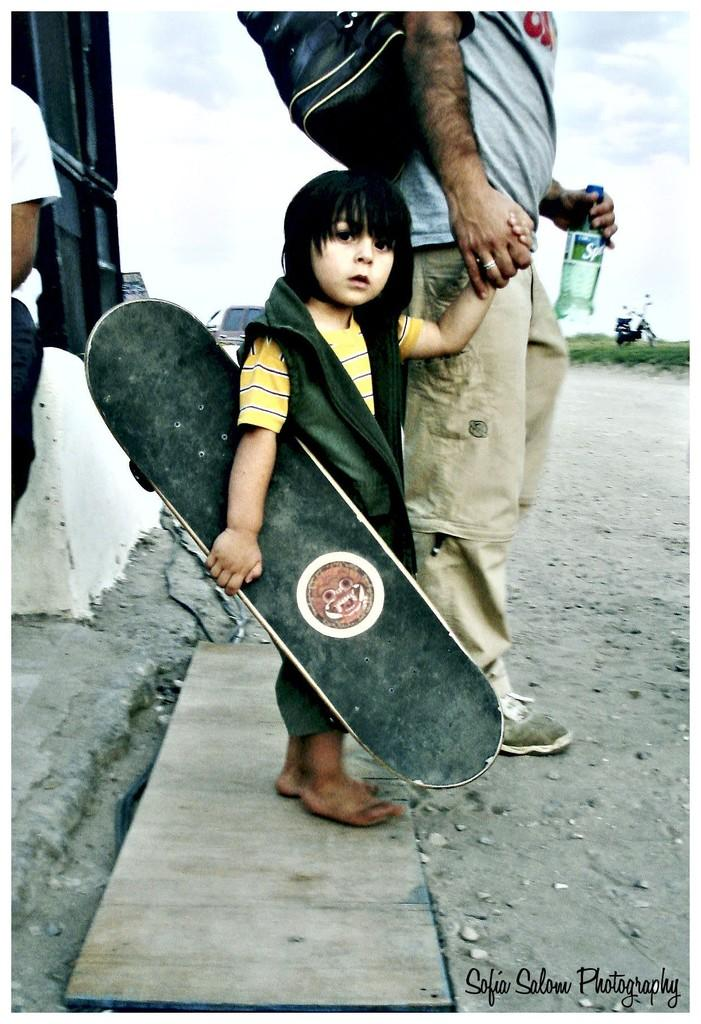What is the main subject of the image? There is a child in the image. What is the child doing in the image? The child is walking and holding a skateboard. Who else is present in the image? There is a man in the image. What is the man doing in the image? The man is walking and wearing a backpack. What can be seen in the background of the image? There is greenery and a bike in the background of the image. What type of cakes is the child cooking in the image? There is no mention of cakes or cooking in the image. 